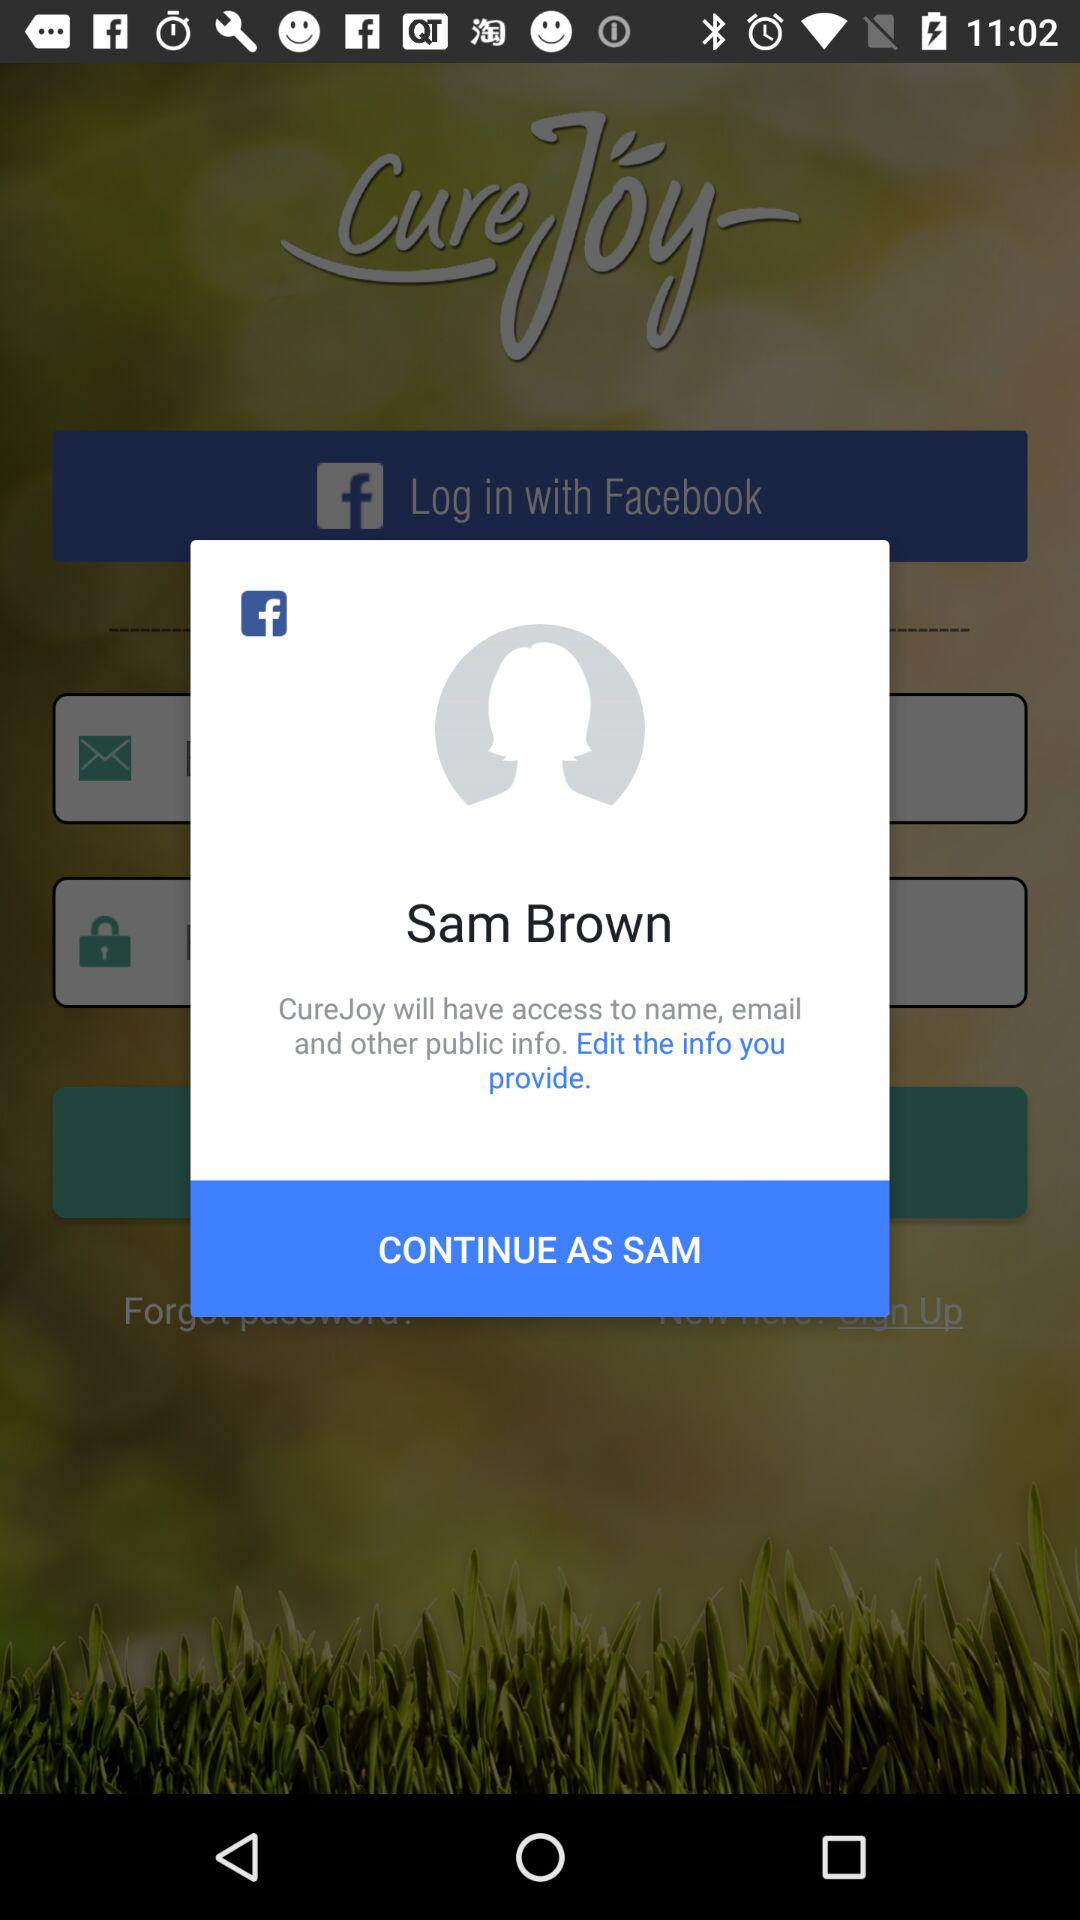What is the user name? The user name is Sam Brown. 